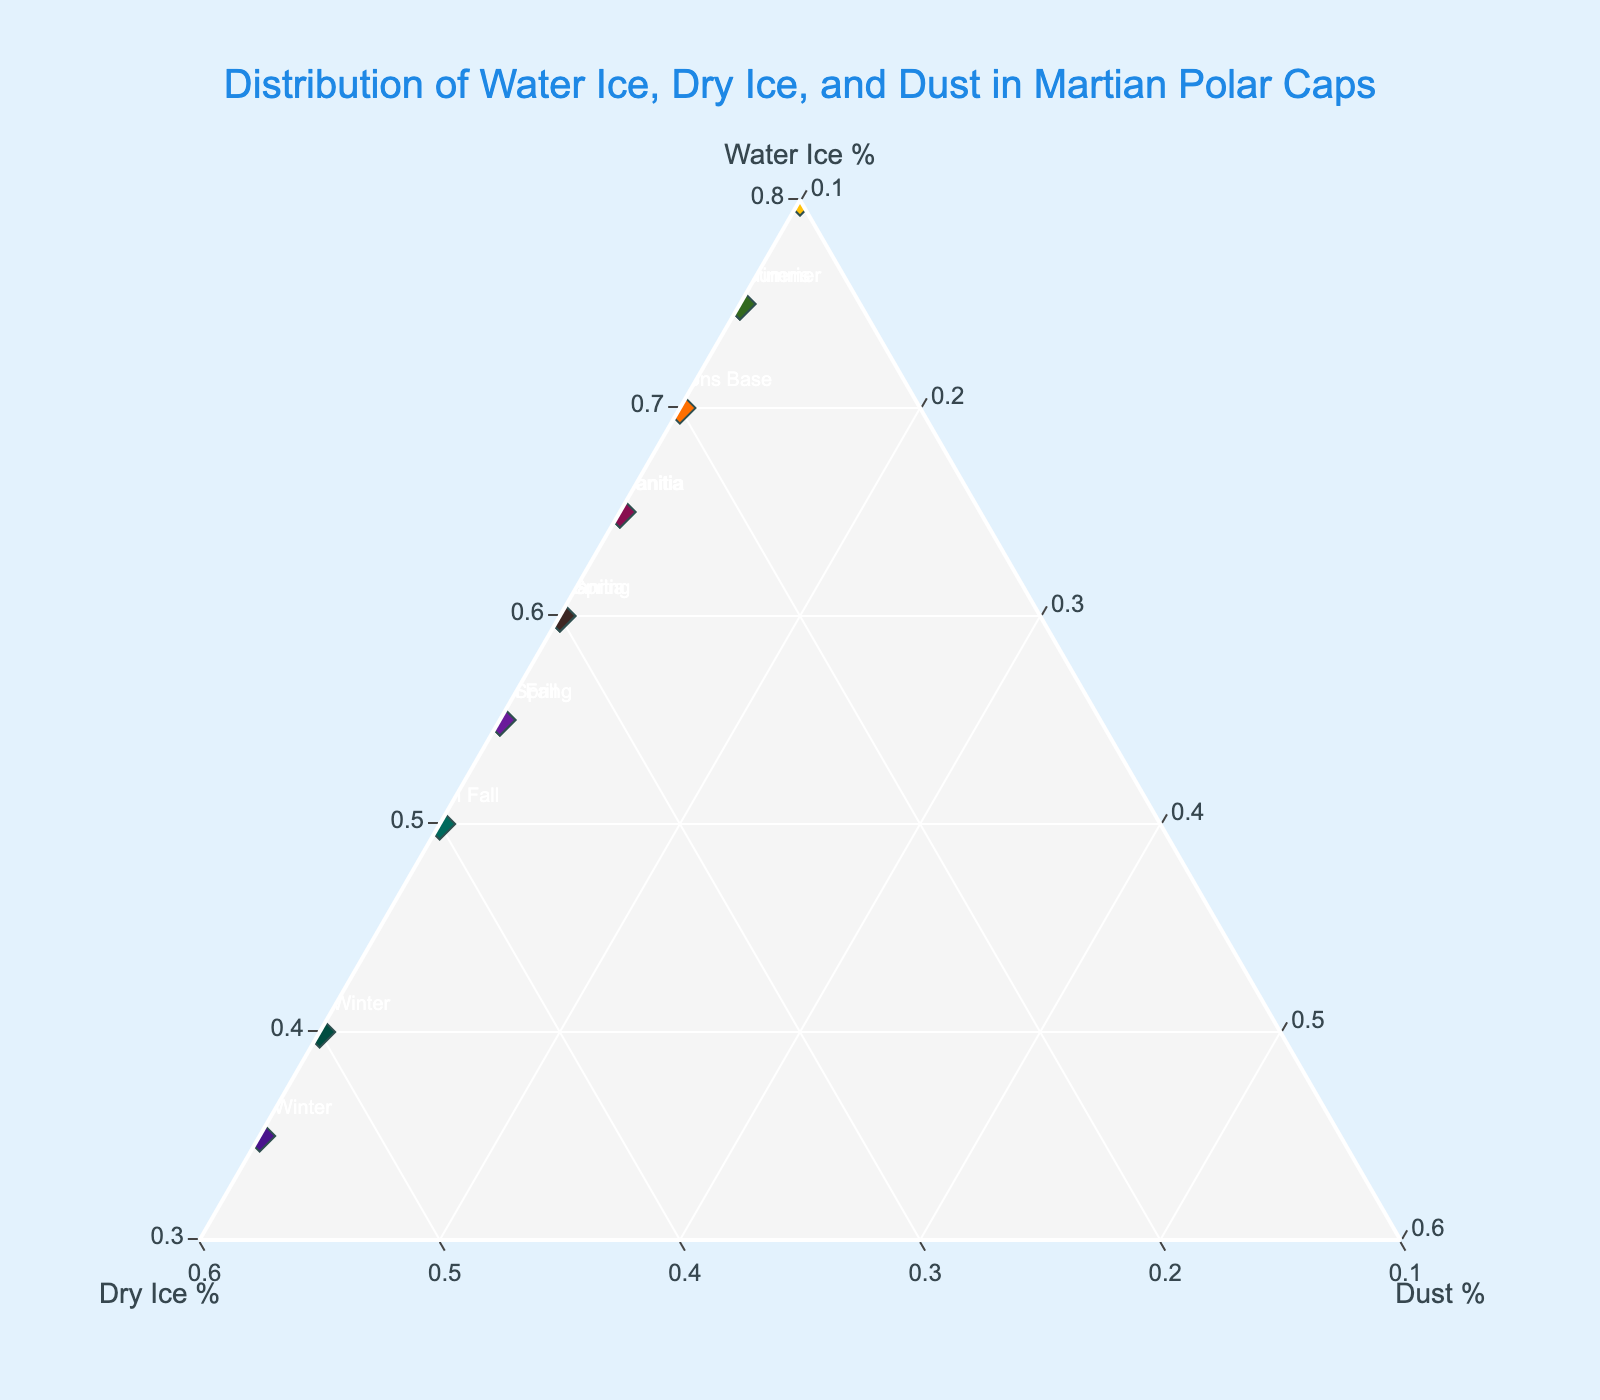How many data points are plotted in the Ternary Plot? The figure shows a data point for each season in both northern and southern hemispheres on Mars, plus four additional locations: Olympus Mons Base, Hellas Planitia, Valles Marineris, and Argyre Planitia. A total of 12 seasons and 5 geographic locations make 17 data points.
Answer: 17 Which season in the Northern Hemisphere shows the highest percentage of Water Ice? By looking at the data points for the Northern Hemisphere seasons: Spring, Summer, Fall, and Winter, Northern Summer has the highest value with 80% Water Ice.
Answer: Northern Summer Compare the Water Ice percentage in Northern Summer and Southern Summer. Which is higher? Northern Summer has 80% Water Ice while Southern Summer has 75%. Northern Summer's percentage is higher when compared.
Answer: Northern Summer What is the sum of Water Ice and Dust percentages for Northern Fall? Northern Fall has 55% Water Ice and 10% Dust. Summing these values gives 55 + 10 = 65%.
Answer: 65% Which season has the highest percentage of Dry Ice in the Southern Hemisphere? By examining Southern Hemisphere seasons: Spring (35%), Summer (15%), Fall (40%), and Winter (55%), Southern Winter has the highest Dry Ice percentage of 55%.
Answer: Southern Winter Finding the average Water Ice percentage across the four seasons in the Northern Hemisphere. Northern Hemisphere seasons have Water Ice percentages of: Spring (60%), Summer (80%), Fall (55%), and Winter (40%). The average is (60 + 80 + 55 + 40) / 4 = 58.75%.
Answer: 58.75% Is there a season or location where the Dust percentage varies from 10%? Reviewing the data, all listed seasons and locations have a Dust percentage of 10%. This means Dust percentage remains constant across all seasons and locations.
Answer: No Which location has the lowest percentage of Dry Ice? By comparing Dry Ice percentages in each location: Olympus Mons Base (20%), Hellas Planitia (25%), Valles Marineris (15%), Argyre Planitia (30%), and Utopia Planitia (25%), Valles Marineris has the lowest with 15%.
Answer: Valles Marineris Which season in the Southern Hemisphere has a similar Water Ice percentage to Northern Spring? Northern Spring has 60% Water Ice. Among Southern Hemisphere seasons, Southern Spring and Argyre Planitia each also have 60% Water Ice.
Answer: Southern Spring, Argyre Planitia Calculate the difference in Dry Ice percentage between Northern Winter and Southern Winter. Northern Winter has 50% Dry Ice and Southern Winter has 55% Dry Ice. The difference is 55 - 50 = 5%.
Answer: 5% 